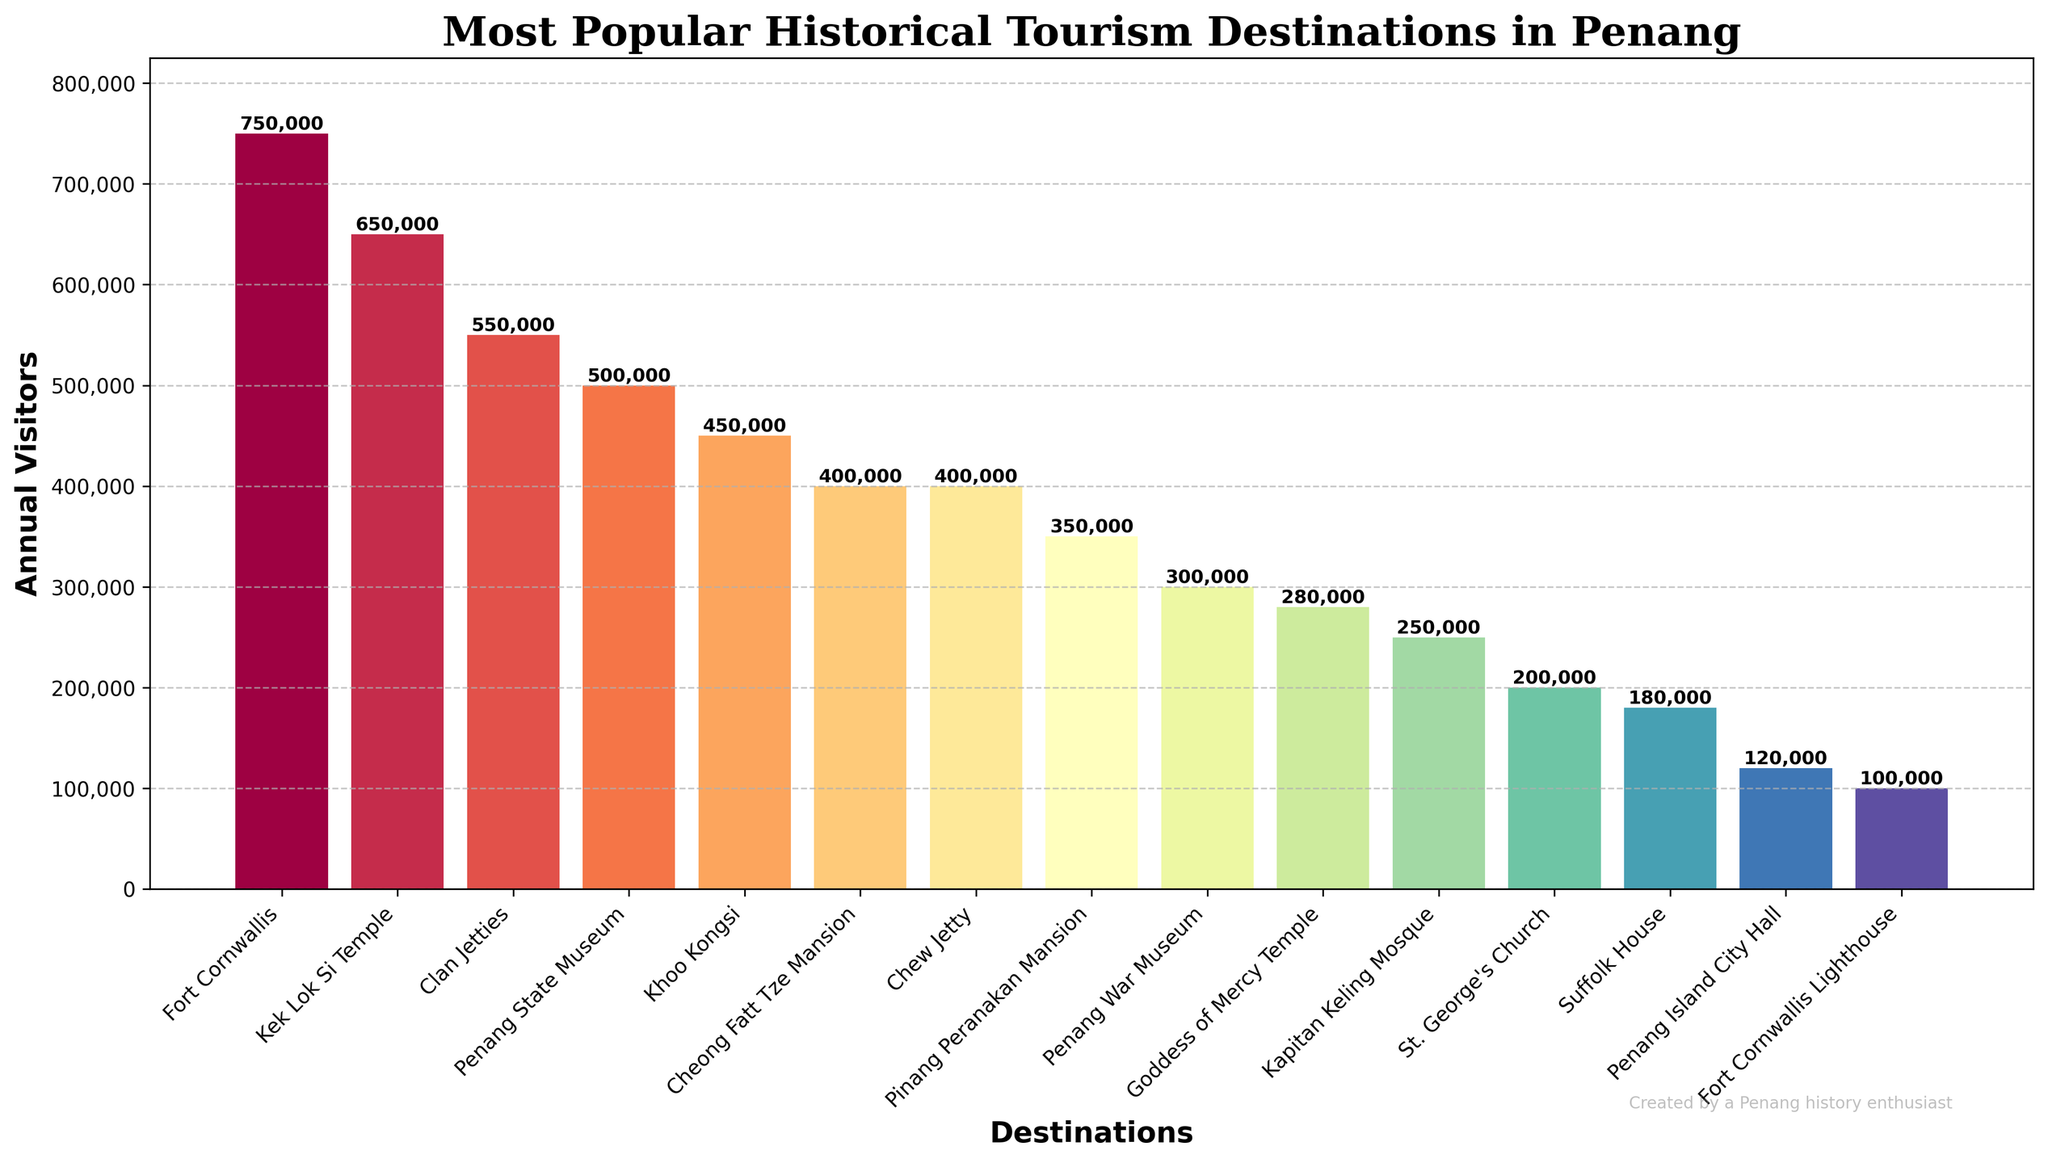Which destination has the highest number of annual visitors? Fort Cornwallis has the highest bar among all the destinations in the bar chart.
Answer: Fort Cornwallis Which destination attracts fewer visitors, Penang War Museum or Clan Jetties? The bar representing Penang War Museum is shorter than the bar for Clan Jetties.
Answer: Penang War Museum What is the sum of the annual visitors to Khoo Kongsi and Cheong Fatt Tze Mansion? Khoo Kongsi has 450,000 visitors, and Cheong Fatt Tze Mansion has 400,000 visitors. The sum is 450,000 + 400,000 = 850,000.
Answer: 850,000 How many visitors does Kek Lok Si Temple have compared to Penang State Museum? Kek Lok Si Temple has 650,000 visitors while Penang State Museum has 500,000 visitors.
Answer: 650,000 > 500,000 Which two destinations have the fewest number of annual visitors, and what are their visitor numbers? The shortest bars are for Penang Island City Hall and Fort Cornwallis Lighthouse, with annual visitors of 120,000 and 100,000 respectively.
Answer: Penang Island City Hall (120,000), Fort Cornwallis Lighthouse (100,000) How many more visitors does Fort Cornwallis have than Pinang Peranakan Mansion? Fort Cornwallis has 750,000 visitors, and Pinang Peranakan Mansion has 350,000 visitors. The difference is 750,000 - 350,000 = 400,000.
Answer: 400,000 What is the median number of visitors among all the destinations? Ordered Visitor Numbers: 100,000, 120,000, 180,000, 200,000, 250,000, 280,000, 300,000, 350,000, 400,000, 400,000, 450,000, 500,000, 550,000, 650,000, 750,000. The median is the middle value: 350,000.
Answer: 350,000 Which destination has the second-highest number of annual visitors? Kek Lok Si Temple has the second highest bar, indicating the second highest number of visitors at 650,000.
Answer: Kek Lok Si Temple How many destinations have more than 400,000 annual visitors? Destinations with more than 400,000 visitors include Fort Cornwallis, Kek Lok Si Temple, Clan Jetties, Khoo Kongsi, and Penang State Museum, totaling five destinations.
Answer: 5 By how much does the visitor number of Goddess of Mercy Temple differ from St. George's Church? Goddess of Mercy Temple has 280,000 visitors and St. George's Church has 200,000 visitors. The difference is 280,000 - 200,000 = 80,000.
Answer: 80,000 